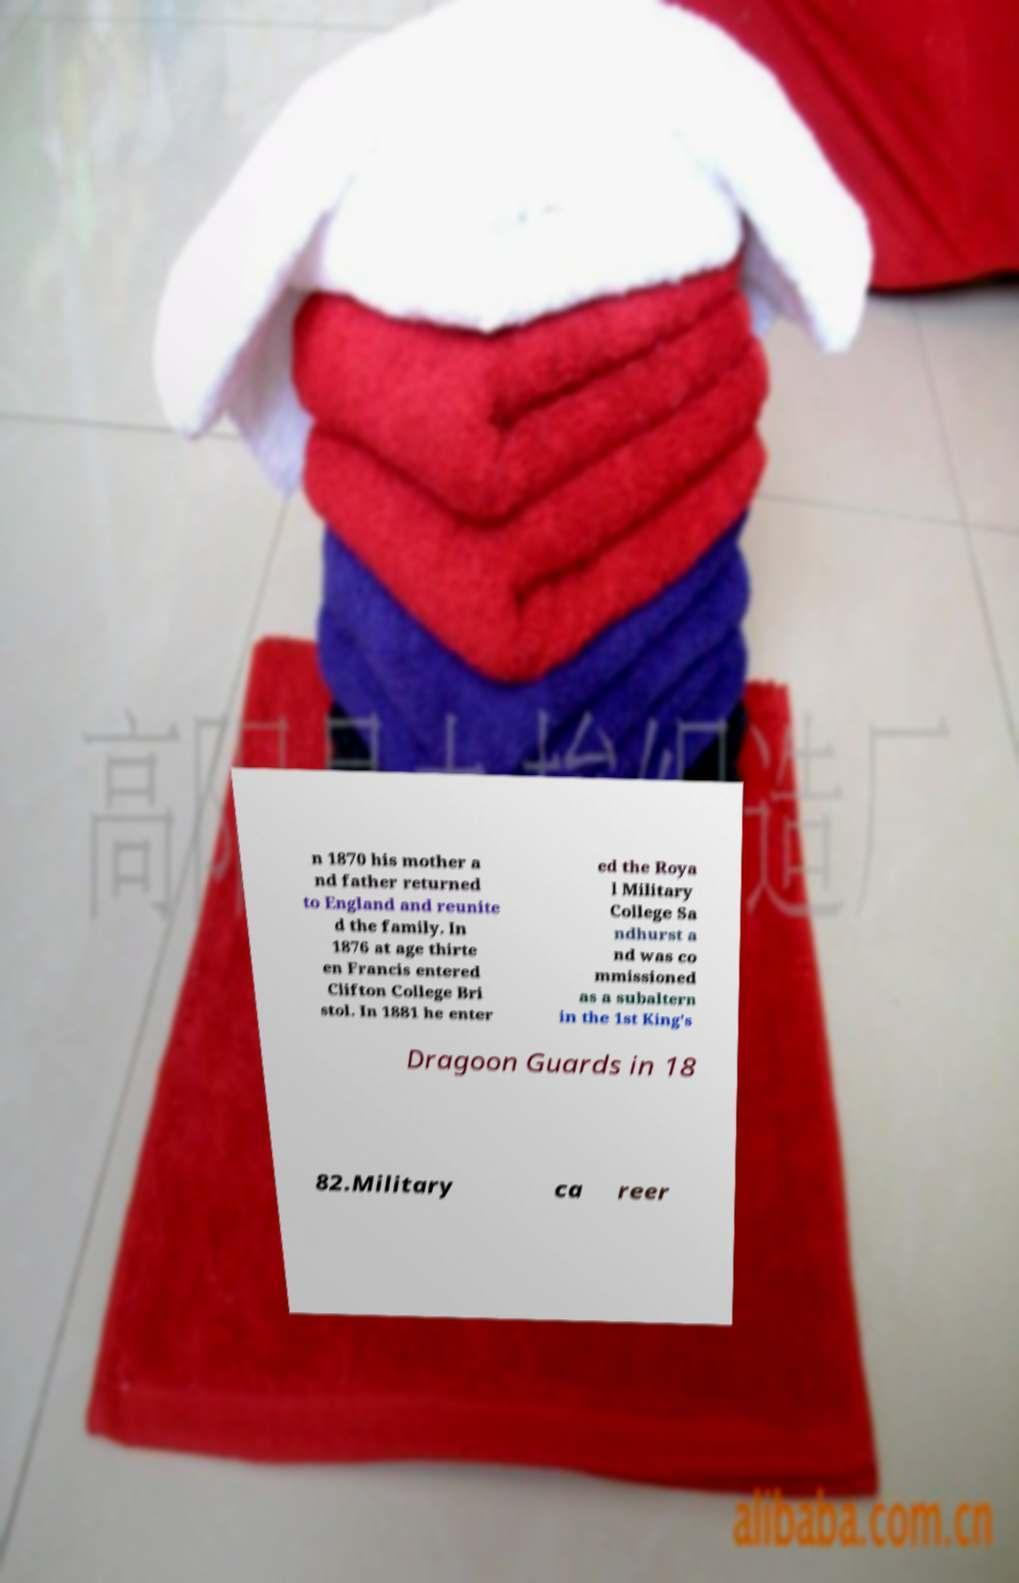I need the written content from this picture converted into text. Can you do that? n 1870 his mother a nd father returned to England and reunite d the family. In 1876 at age thirte en Francis entered Clifton College Bri stol. In 1881 he enter ed the Roya l Military College Sa ndhurst a nd was co mmissioned as a subaltern in the 1st King's Dragoon Guards in 18 82.Military ca reer 